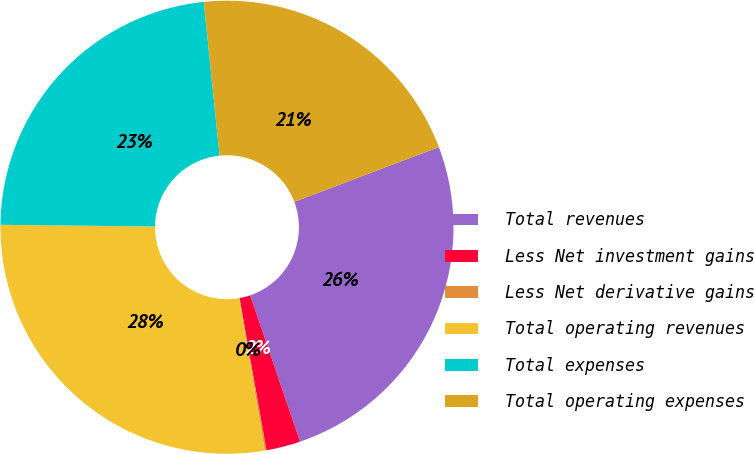Convert chart. <chart><loc_0><loc_0><loc_500><loc_500><pie_chart><fcel>Total revenues<fcel>Less Net investment gains<fcel>Less Net derivative gains<fcel>Total operating revenues<fcel>Total expenses<fcel>Total operating expenses<nl><fcel>25.52%<fcel>2.44%<fcel>0.12%<fcel>27.84%<fcel>23.2%<fcel>20.88%<nl></chart> 